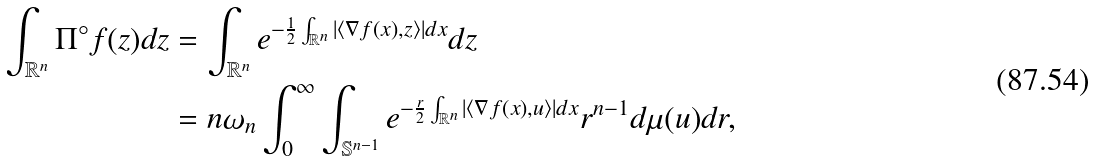<formula> <loc_0><loc_0><loc_500><loc_500>\int _ { \mathbb { R } ^ { n } } \Pi ^ { \circ } f ( z ) d z & = \int _ { \mathbb { R } ^ { n } } e ^ { - \frac { 1 } { 2 } \int _ { \mathbb { R } ^ { n } } | \langle \nabla f ( x ) , z \rangle | d x } d z \\ & = n \omega _ { n } \int _ { 0 } ^ { \infty } \int _ { \mathbb { S } ^ { n - 1 } } e ^ { - \frac { r } { 2 } \int _ { \mathbb { R } ^ { n } } | \langle \nabla f ( x ) , u \rangle | d x } r ^ { n - 1 } d \mu ( u ) d r ,</formula> 